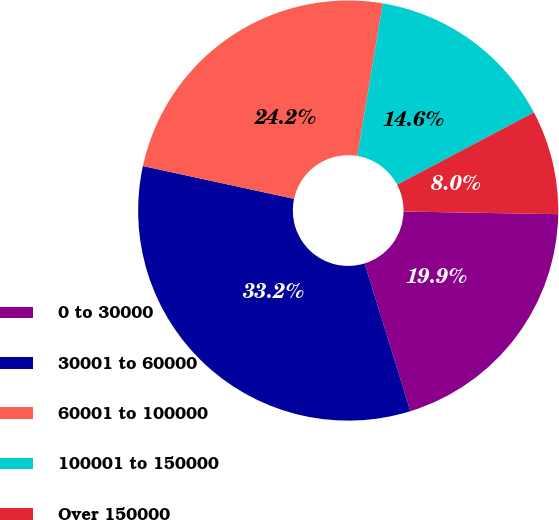Convert chart. <chart><loc_0><loc_0><loc_500><loc_500><pie_chart><fcel>0 to 30000<fcel>30001 to 60000<fcel>60001 to 100000<fcel>100001 to 150000<fcel>Over 150000<nl><fcel>19.94%<fcel>33.18%<fcel>24.23%<fcel>14.63%<fcel>8.01%<nl></chart> 